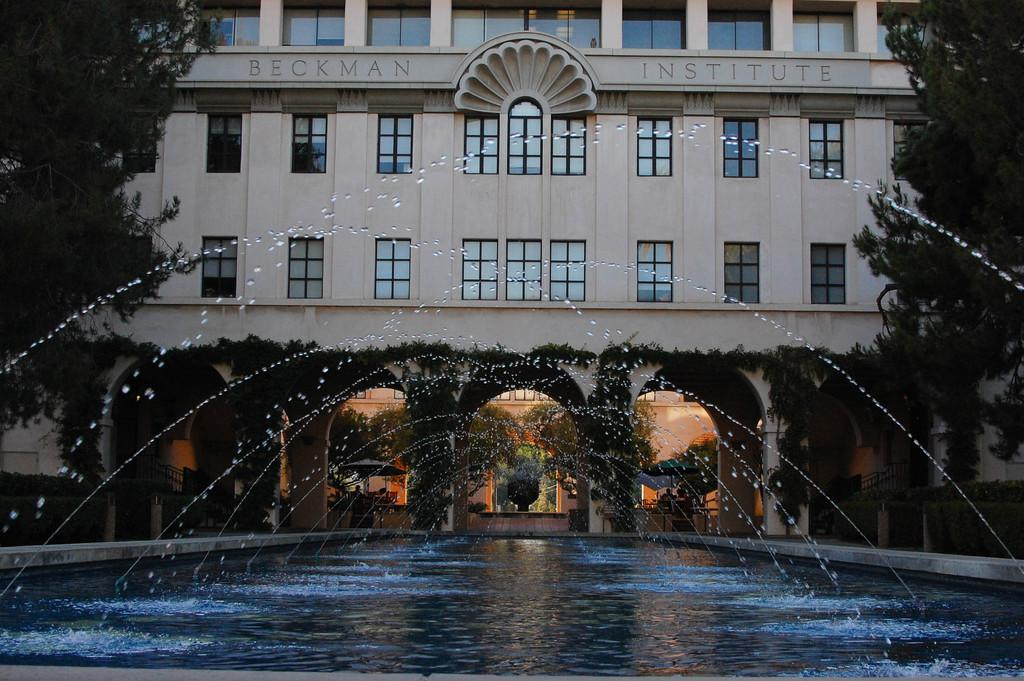What is at the bottom of the image? There is water at the bottom of the image. What can be seen in the background of the image? There are trees and a building in the background of the image. How many times does the person jump in the image? There is no person present in the image, so it is not possible to determine how many times they jump. 